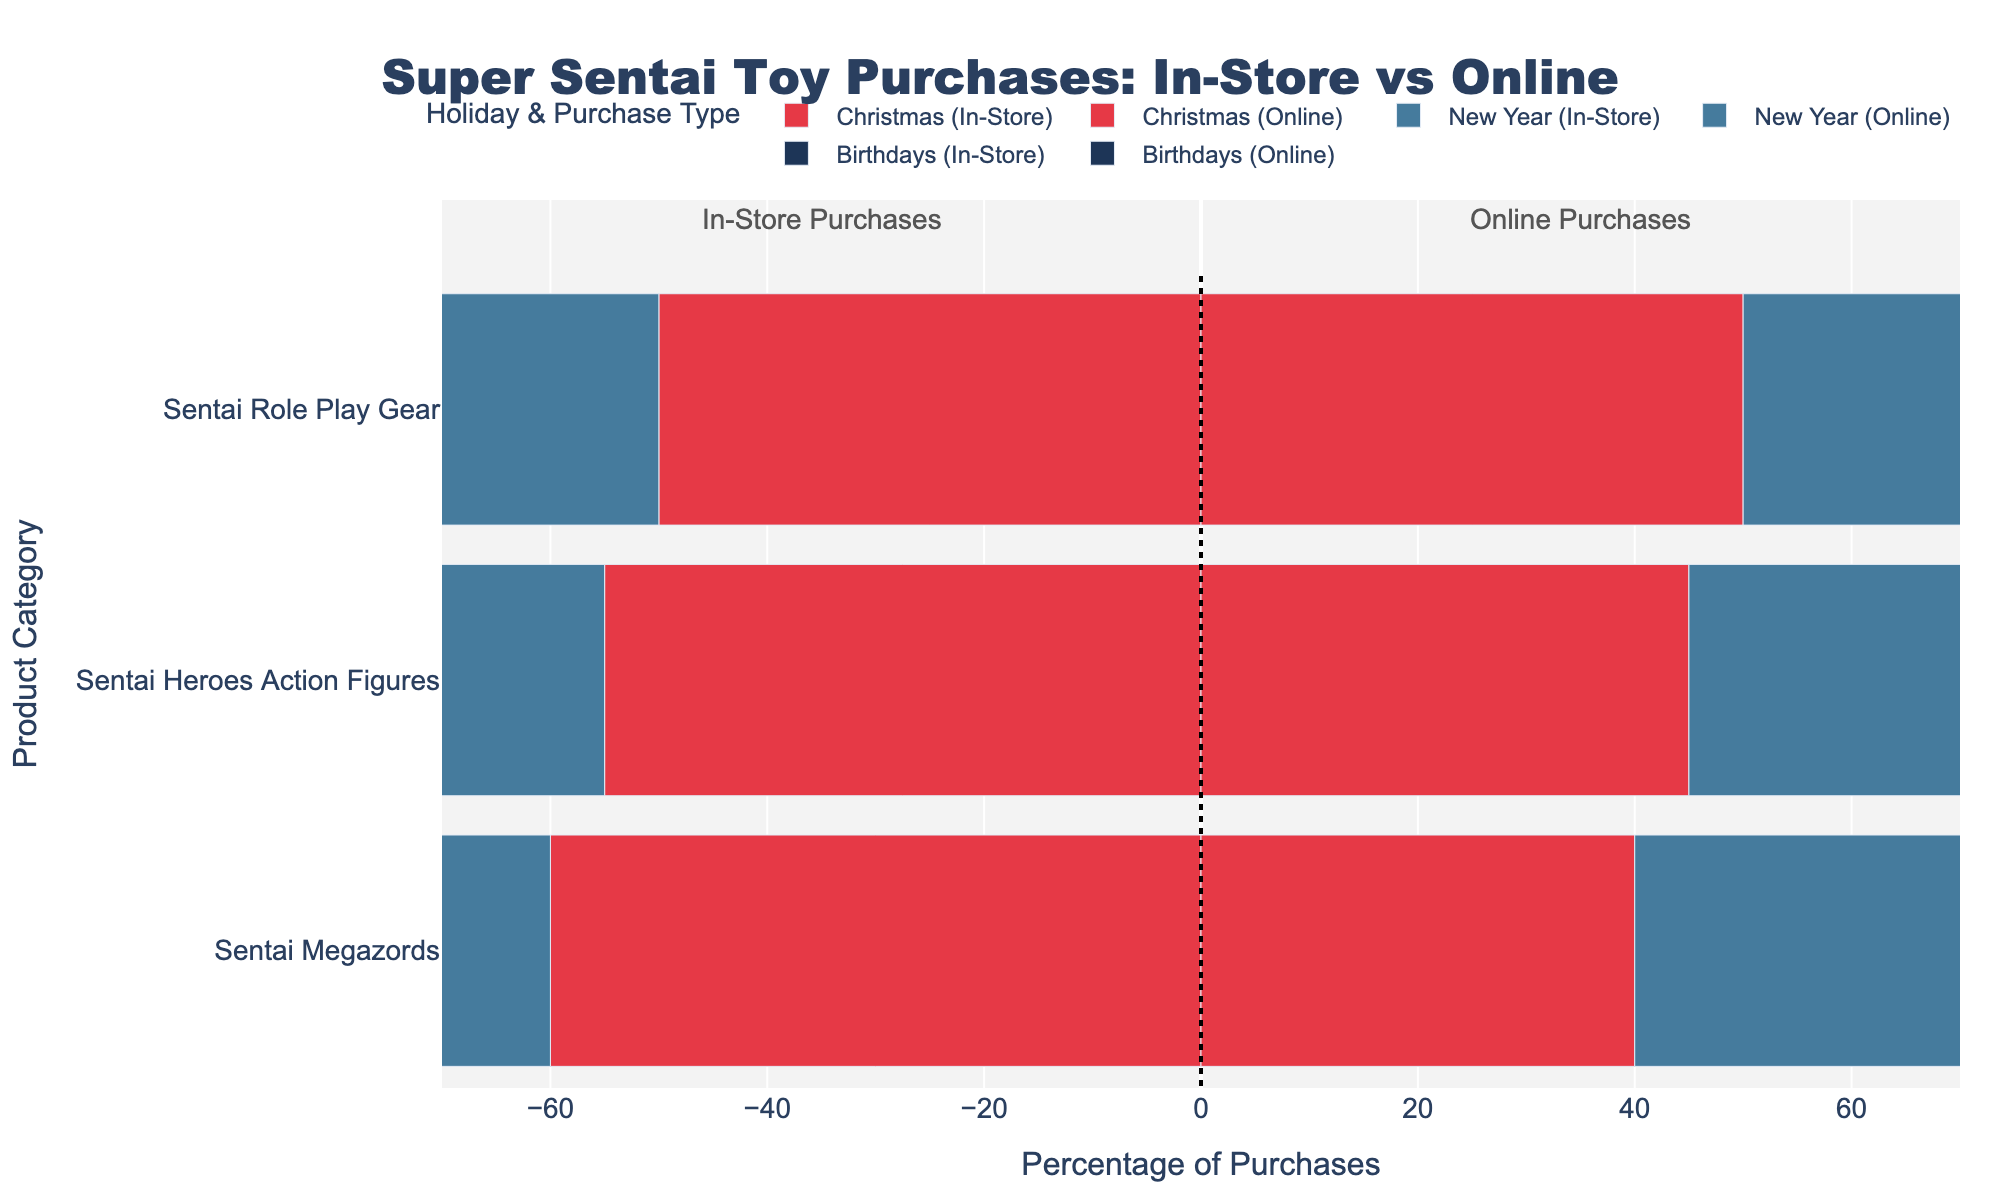What is the proportion of in-store versus online purchases of "Sentai Role Play Gear" during Christmas? During Christmas, the chart shows that in-store purchases constitute 50%, and online purchases also constitute 50% for Sentai Role Play Gear. Thus, the proportion is equal.
Answer: 50% in-store, 50% online Which holiday has the highest percentage of online purchases for "Sentai Heroes Action Figures"? For "Sentai Heroes Action Figures," the percentage of online purchases is 45% during Christmas, 48% during New Year, and 52% during Birthdays. Birthdays have the highest percentage of online purchases at 52%.
Answer: Birthdays How does the proportion of in-store and online purchases of "Sentai Megazords" during New Year compare? The chart indicates that for Sentai Megazords during New Year, 58% of purchases are in-store, and 42% are online. This shows a higher proportion of in-store purchases compared to online.
Answer: 58% in-store, 42% online Which product category has the largest difference in proportion between in-store and online purchases during Birthdays? During Birthdays, Sentai Heroes Action Figures have a 48:52 split, Sentai Megazords have a 50:50 split, and Sentai Role Play Gear has a 40:60 split. The largest difference is for Sentai Role Play Gear at 20% (40% in-store vs 60% online).
Answer: Sentai Role Play Gear What's the average percentage of in-store purchases for "Sentai Role Play Gear" across all holidays? To find the average, add the percentages of in-store purchases for "Sentai Role Play Gear" across Christmas (50%), New Year (45%), and Birthdays (40%), then divide by 3. The average is (50 + 45 + 40) / 3 = 45%.
Answer: 45% On which holiday is the difference between in-store and online purchases the smallest for "Sentai Megazords"? For Sentai Megazords, the difference between in-store and online purchases is 20% during Christmas (60% in-store, 40% online), 16% during New Year (58% in-store, 42% online), and 0% during Birthdays (50% in-store, 50% online). The smallest difference is during Birthdays.
Answer: Birthdays Which holiday has the highest overall percentage of in-store purchases across all product categories? To determine the highest, compare the in-store purchase percentages across all categories for each holiday. Christmas: 55%, 60%, 50%. New Year: 52%, 58%, 45%. Birthdays: 48%, 50%, 40%. Summing them, Christmas has the highest total: 165%.
Answer: Christmas 